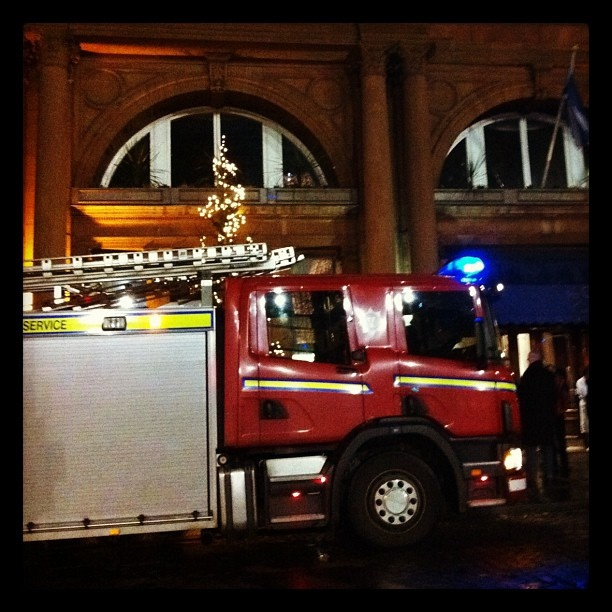Describe the objects in this image and their specific colors. I can see truck in black, darkgray, maroon, and lightgray tones, people in black, maroon, and brown tones, potted plant in black, maroon, and gray tones, potted plant in black, gray, and darkgray tones, and people in black, darkgray, and gray tones in this image. 